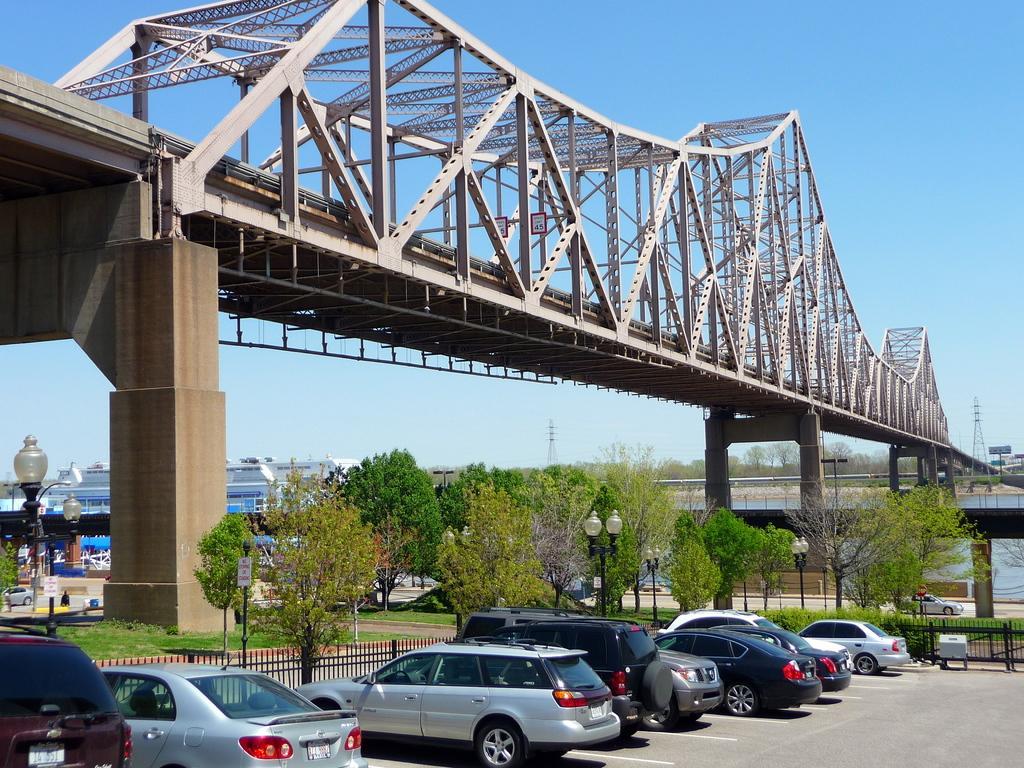Describe this image in one or two sentences. In this picture there are few vehicles parked and there is a bridge above it and there are trees and buildings in the background. 